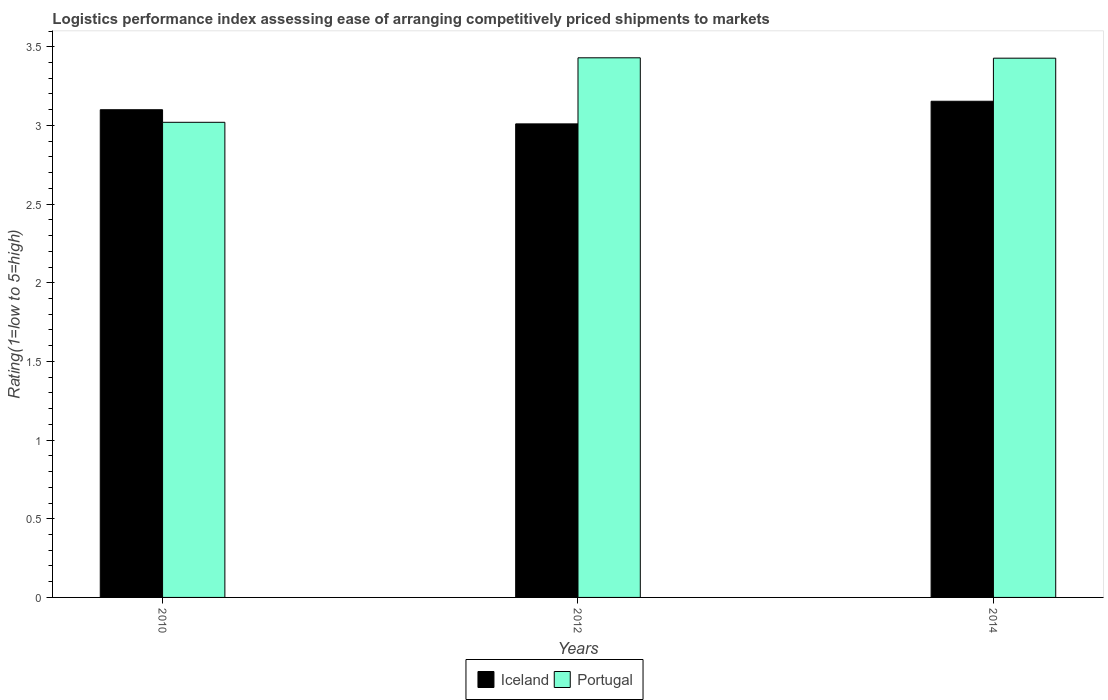How many different coloured bars are there?
Provide a short and direct response. 2. Across all years, what is the maximum Logistic performance index in Portugal?
Offer a terse response. 3.43. Across all years, what is the minimum Logistic performance index in Portugal?
Offer a terse response. 3.02. In which year was the Logistic performance index in Portugal minimum?
Give a very brief answer. 2010. What is the total Logistic performance index in Iceland in the graph?
Offer a very short reply. 9.26. What is the difference between the Logistic performance index in Iceland in 2010 and that in 2014?
Your response must be concise. -0.05. What is the difference between the Logistic performance index in Iceland in 2014 and the Logistic performance index in Portugal in 2012?
Make the answer very short. -0.28. What is the average Logistic performance index in Iceland per year?
Your answer should be very brief. 3.09. In the year 2012, what is the difference between the Logistic performance index in Portugal and Logistic performance index in Iceland?
Keep it short and to the point. 0.42. What is the ratio of the Logistic performance index in Portugal in 2012 to that in 2014?
Keep it short and to the point. 1. Is the Logistic performance index in Portugal in 2012 less than that in 2014?
Offer a terse response. No. Is the difference between the Logistic performance index in Portugal in 2010 and 2012 greater than the difference between the Logistic performance index in Iceland in 2010 and 2012?
Provide a short and direct response. No. What is the difference between the highest and the second highest Logistic performance index in Portugal?
Give a very brief answer. 0. What is the difference between the highest and the lowest Logistic performance index in Portugal?
Your answer should be compact. 0.41. Is the sum of the Logistic performance index in Portugal in 2010 and 2014 greater than the maximum Logistic performance index in Iceland across all years?
Your response must be concise. Yes. What does the 1st bar from the left in 2012 represents?
Your response must be concise. Iceland. How many years are there in the graph?
Ensure brevity in your answer.  3. What is the difference between two consecutive major ticks on the Y-axis?
Provide a short and direct response. 0.5. Does the graph contain grids?
Your response must be concise. No. Where does the legend appear in the graph?
Offer a very short reply. Bottom center. What is the title of the graph?
Your response must be concise. Logistics performance index assessing ease of arranging competitively priced shipments to markets. Does "Monaco" appear as one of the legend labels in the graph?
Give a very brief answer. No. What is the label or title of the Y-axis?
Ensure brevity in your answer.  Rating(1=low to 5=high). What is the Rating(1=low to 5=high) in Portugal in 2010?
Provide a short and direct response. 3.02. What is the Rating(1=low to 5=high) of Iceland in 2012?
Your answer should be compact. 3.01. What is the Rating(1=low to 5=high) in Portugal in 2012?
Provide a short and direct response. 3.43. What is the Rating(1=low to 5=high) in Iceland in 2014?
Ensure brevity in your answer.  3.15. What is the Rating(1=low to 5=high) of Portugal in 2014?
Your response must be concise. 3.43. Across all years, what is the maximum Rating(1=low to 5=high) of Iceland?
Provide a short and direct response. 3.15. Across all years, what is the maximum Rating(1=low to 5=high) in Portugal?
Provide a succinct answer. 3.43. Across all years, what is the minimum Rating(1=low to 5=high) in Iceland?
Provide a short and direct response. 3.01. Across all years, what is the minimum Rating(1=low to 5=high) of Portugal?
Your response must be concise. 3.02. What is the total Rating(1=low to 5=high) of Iceland in the graph?
Your answer should be compact. 9.26. What is the total Rating(1=low to 5=high) in Portugal in the graph?
Ensure brevity in your answer.  9.88. What is the difference between the Rating(1=low to 5=high) in Iceland in 2010 and that in 2012?
Make the answer very short. 0.09. What is the difference between the Rating(1=low to 5=high) of Portugal in 2010 and that in 2012?
Make the answer very short. -0.41. What is the difference between the Rating(1=low to 5=high) in Iceland in 2010 and that in 2014?
Your answer should be compact. -0.05. What is the difference between the Rating(1=low to 5=high) of Portugal in 2010 and that in 2014?
Provide a short and direct response. -0.41. What is the difference between the Rating(1=low to 5=high) in Iceland in 2012 and that in 2014?
Make the answer very short. -0.14. What is the difference between the Rating(1=low to 5=high) of Portugal in 2012 and that in 2014?
Offer a terse response. 0. What is the difference between the Rating(1=low to 5=high) in Iceland in 2010 and the Rating(1=low to 5=high) in Portugal in 2012?
Ensure brevity in your answer.  -0.33. What is the difference between the Rating(1=low to 5=high) of Iceland in 2010 and the Rating(1=low to 5=high) of Portugal in 2014?
Provide a succinct answer. -0.33. What is the difference between the Rating(1=low to 5=high) of Iceland in 2012 and the Rating(1=low to 5=high) of Portugal in 2014?
Your response must be concise. -0.42. What is the average Rating(1=low to 5=high) in Iceland per year?
Your answer should be compact. 3.09. What is the average Rating(1=low to 5=high) of Portugal per year?
Your answer should be very brief. 3.29. In the year 2012, what is the difference between the Rating(1=low to 5=high) in Iceland and Rating(1=low to 5=high) in Portugal?
Your answer should be very brief. -0.42. In the year 2014, what is the difference between the Rating(1=low to 5=high) of Iceland and Rating(1=low to 5=high) of Portugal?
Provide a short and direct response. -0.27. What is the ratio of the Rating(1=low to 5=high) of Iceland in 2010 to that in 2012?
Your answer should be very brief. 1.03. What is the ratio of the Rating(1=low to 5=high) in Portugal in 2010 to that in 2012?
Keep it short and to the point. 0.88. What is the ratio of the Rating(1=low to 5=high) of Iceland in 2010 to that in 2014?
Your answer should be compact. 0.98. What is the ratio of the Rating(1=low to 5=high) of Portugal in 2010 to that in 2014?
Offer a terse response. 0.88. What is the ratio of the Rating(1=low to 5=high) in Iceland in 2012 to that in 2014?
Keep it short and to the point. 0.95. What is the ratio of the Rating(1=low to 5=high) in Portugal in 2012 to that in 2014?
Offer a terse response. 1. What is the difference between the highest and the second highest Rating(1=low to 5=high) in Iceland?
Make the answer very short. 0.05. What is the difference between the highest and the second highest Rating(1=low to 5=high) in Portugal?
Ensure brevity in your answer.  0. What is the difference between the highest and the lowest Rating(1=low to 5=high) in Iceland?
Ensure brevity in your answer.  0.14. What is the difference between the highest and the lowest Rating(1=low to 5=high) in Portugal?
Make the answer very short. 0.41. 